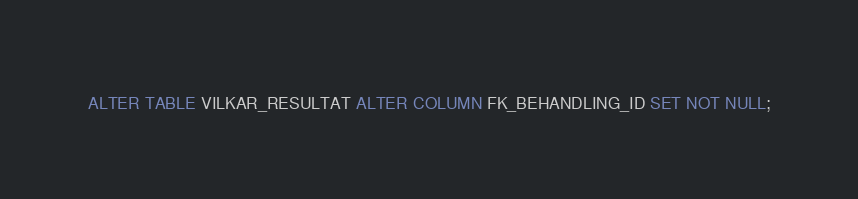Convert code to text. <code><loc_0><loc_0><loc_500><loc_500><_SQL_>ALTER TABLE VILKAR_RESULTAT ALTER COLUMN FK_BEHANDLING_ID SET NOT NULL;</code> 